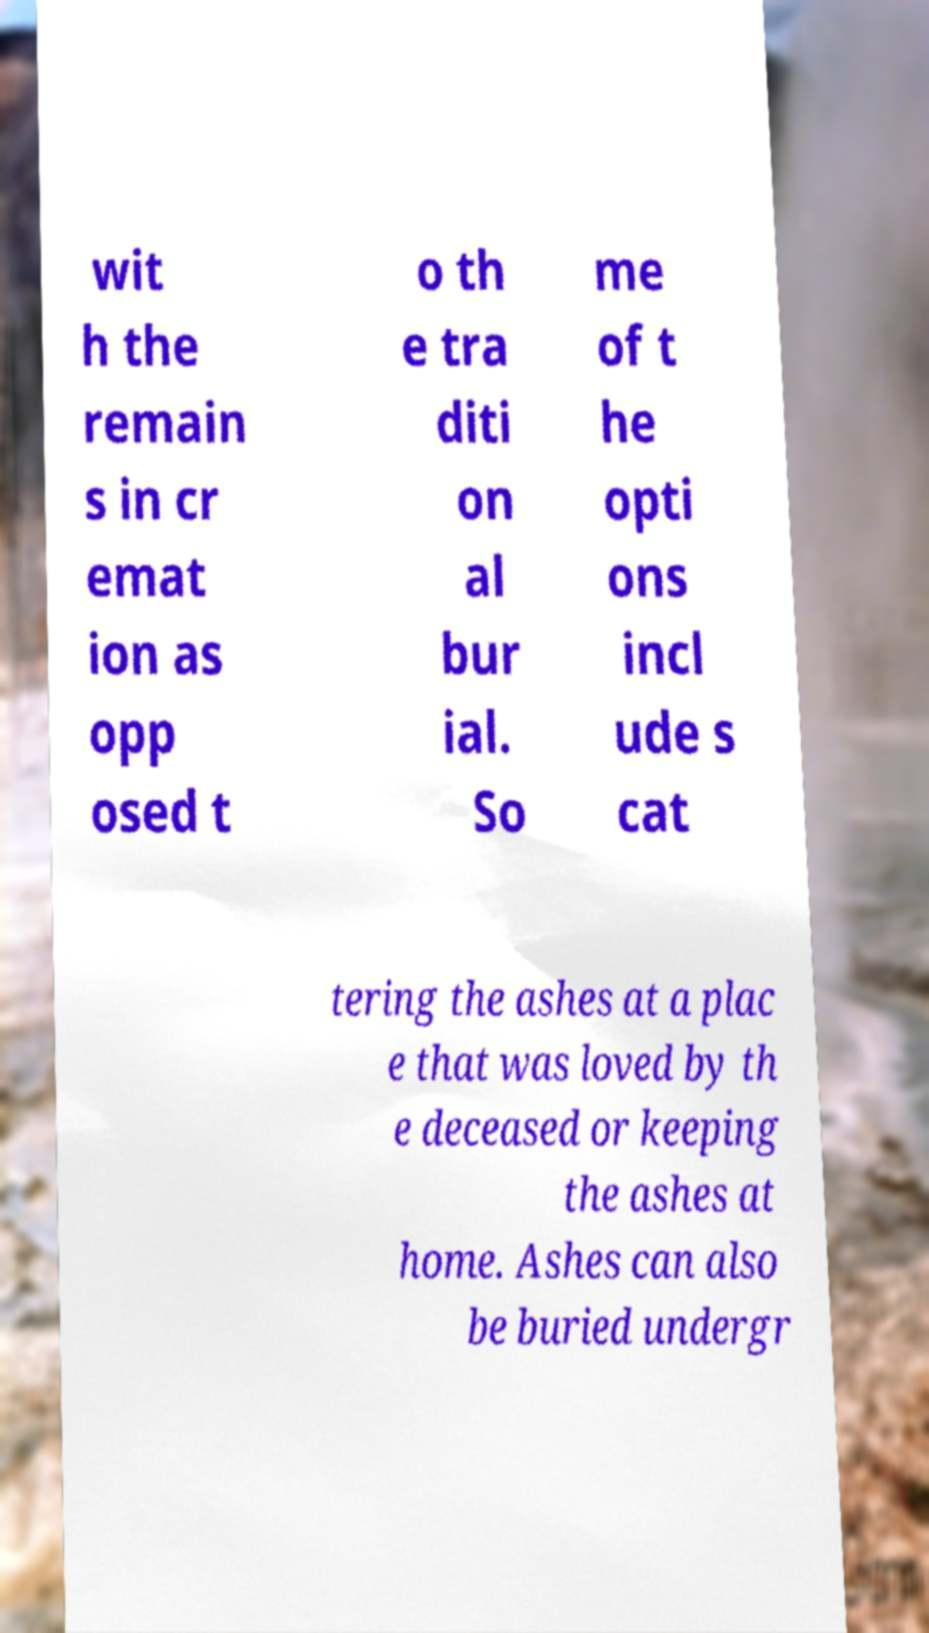Can you read and provide the text displayed in the image?This photo seems to have some interesting text. Can you extract and type it out for me? wit h the remain s in cr emat ion as opp osed t o th e tra diti on al bur ial. So me of t he opti ons incl ude s cat tering the ashes at a plac e that was loved by th e deceased or keeping the ashes at home. Ashes can also be buried undergr 